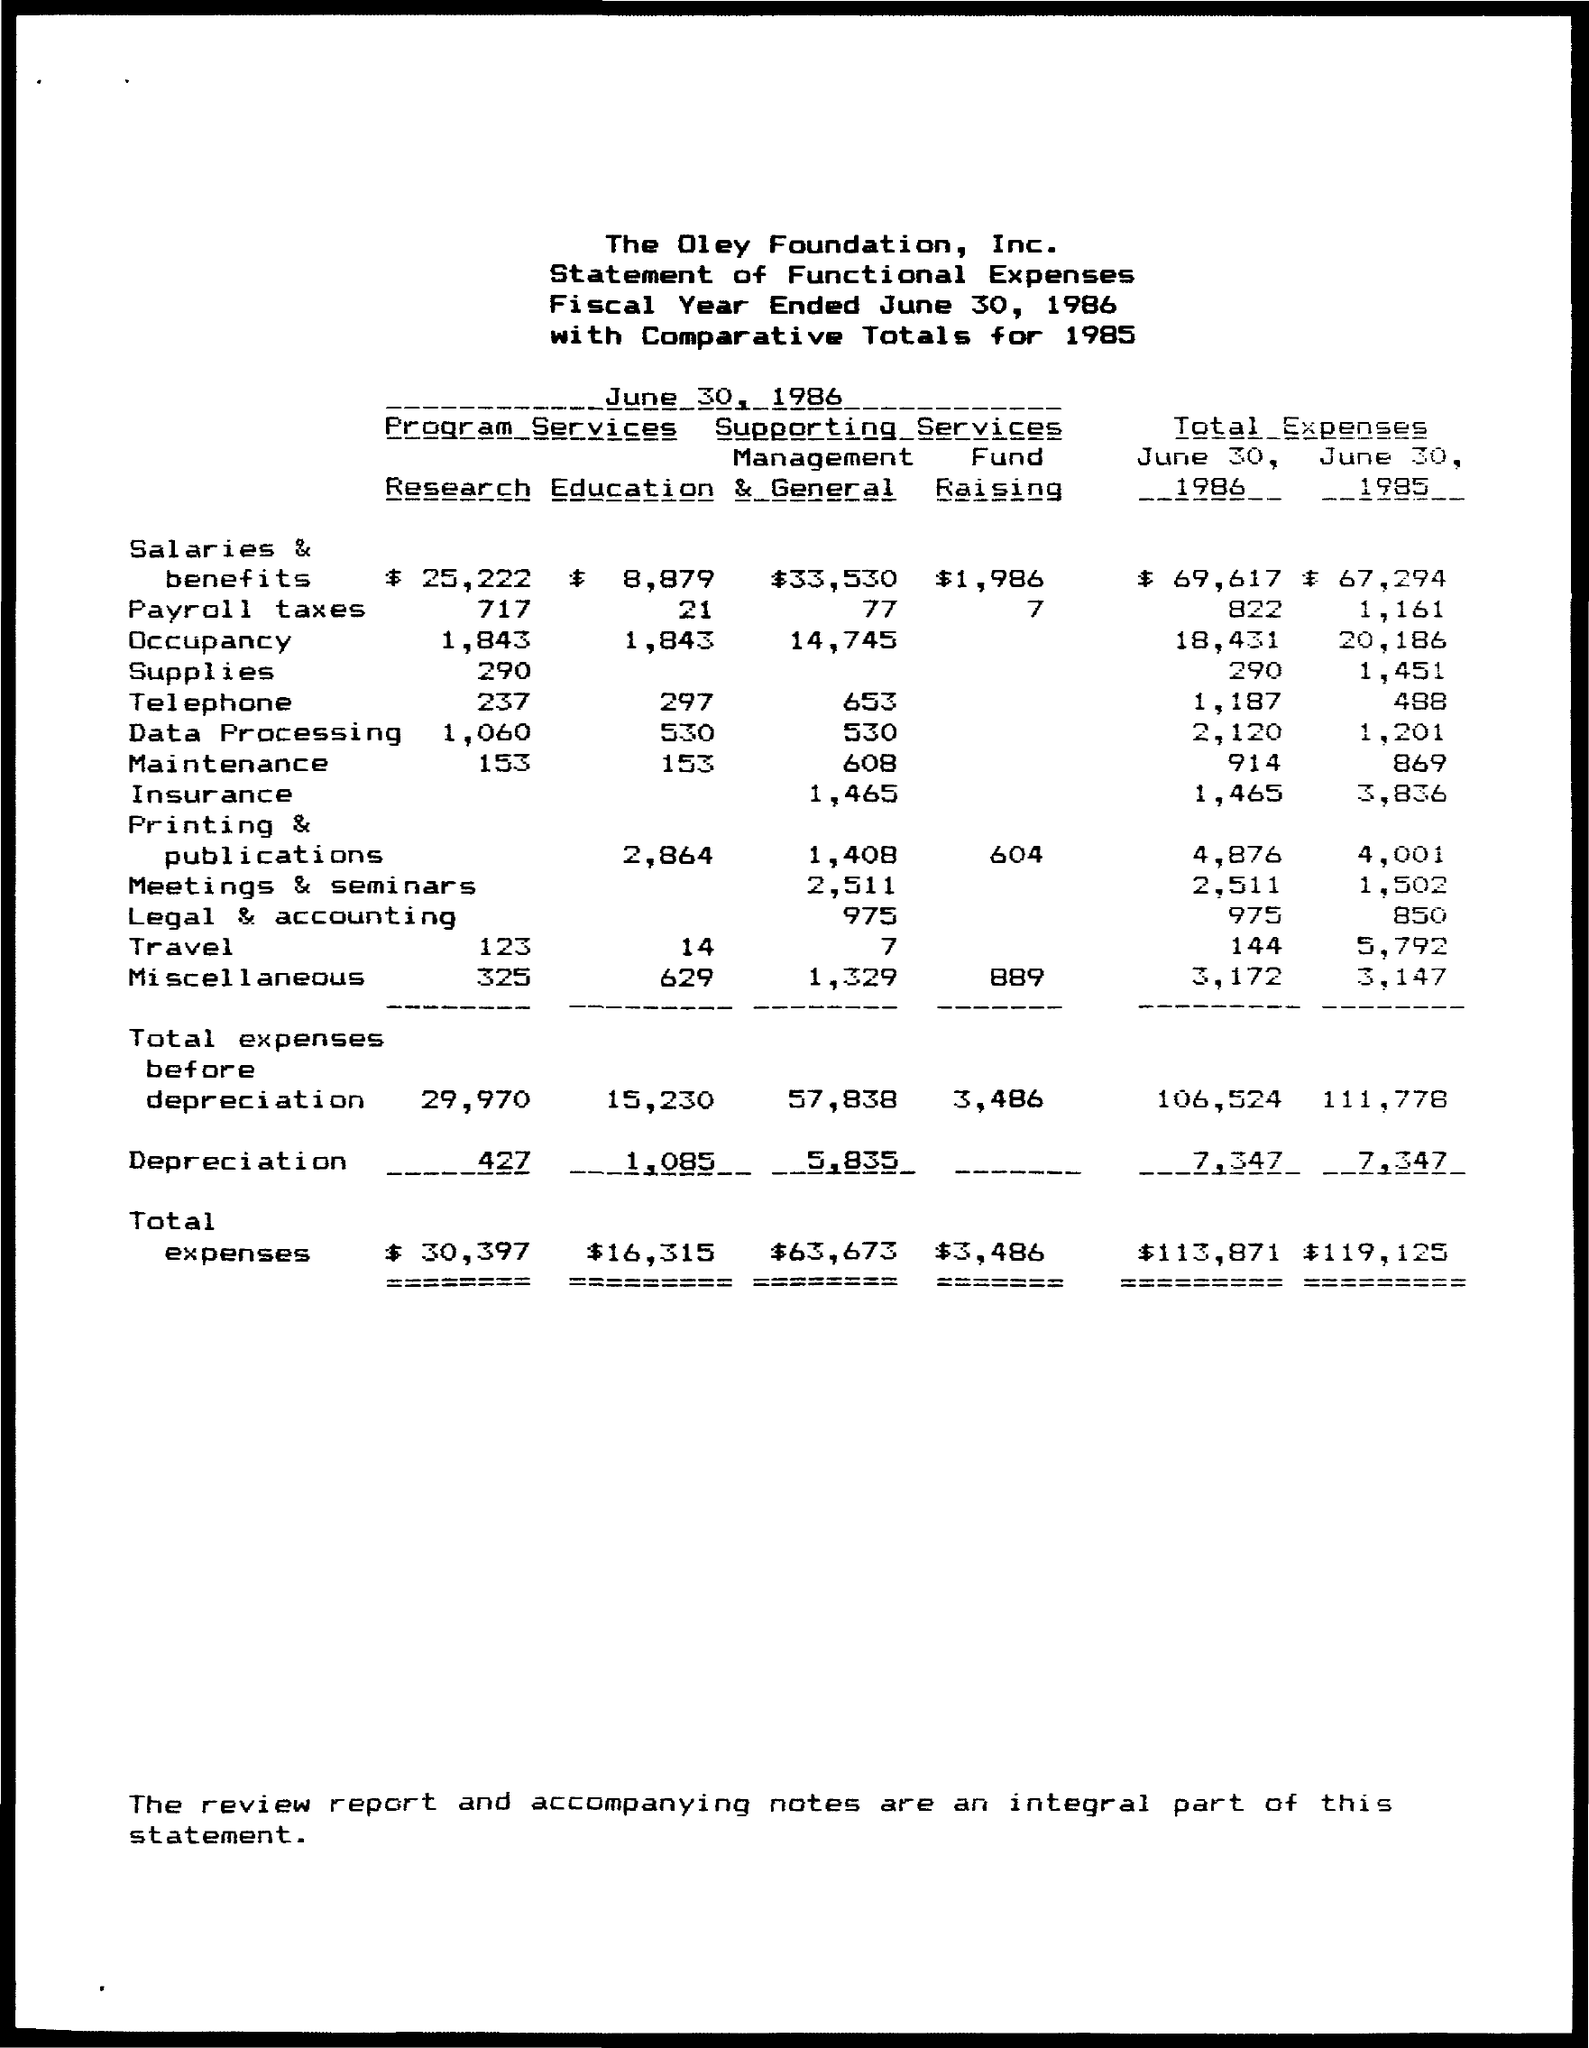Point out several critical features in this image. The total expenses for salaries and benefits for June 30, 1986 were $69,617. The total expenses for occupancy for June 30, 1986 were $18,431. The total expenses for salaries and benefits for June 30, 1985 were $67,294. The total expenses for occupancy for June 30, 1985, were 20,186. The total expenses for telephone for June 30, 1986, were 1,187. 